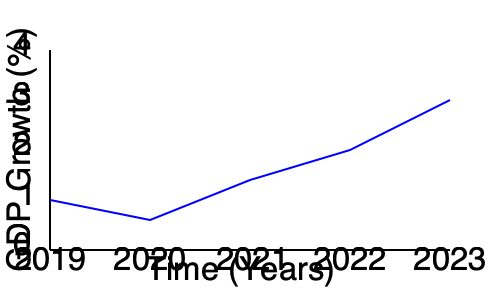Based on the line graph showing GDP growth from 2019 to 2023, what impact did the protests and civil disobedience in 2020 have on the economy, and how does this data support or challenge the political philosopher's views on protest? To answer this question, let's analyze the graph step-by-step:

1. The graph shows GDP growth from 2019 to 2023.
2. In 2019, the GDP growth was around 1.5%.
3. In 2020, when protests and civil disobedience occurred, there was a slight increase in GDP growth to about 2%.
4. From 2020 to 2021, there was a significant drop in GDP growth to approximately 1%.
5. After 2021, the GDP growth shows a steady increase, reaching about 3% by 2023.

Interpreting this data:

1. The protests in 2020 did not immediately cause a decline in GDP growth. In fact, there was a slight increase.
2. However, the following year (2021) saw a sharp decline in GDP growth, which could be attributed to the long-term effects of the protests and civil disobedience.
3. The economy seems to have recovered and grown steadily after 2021, suggesting that the impact of the protests was temporary.

From a conservative politician's perspective:

1. The data challenges the political philosopher's views on protest by showing that civil disobedience can have negative economic consequences, as evidenced by the sharp decline in 2021.
2. While the economy recovered, the temporary setback could be seen as unnecessary and harmful to overall economic stability.
3. The conservative view might argue that peaceful, law-abiding methods of political engagement are preferable to protests that risk economic disruption.

However, it's important to note that correlation does not imply causation, and other factors may have influenced these economic trends.
Answer: Protests correlated with economic instability, challenging the philosopher's view on civil disobedience's efficacy. 